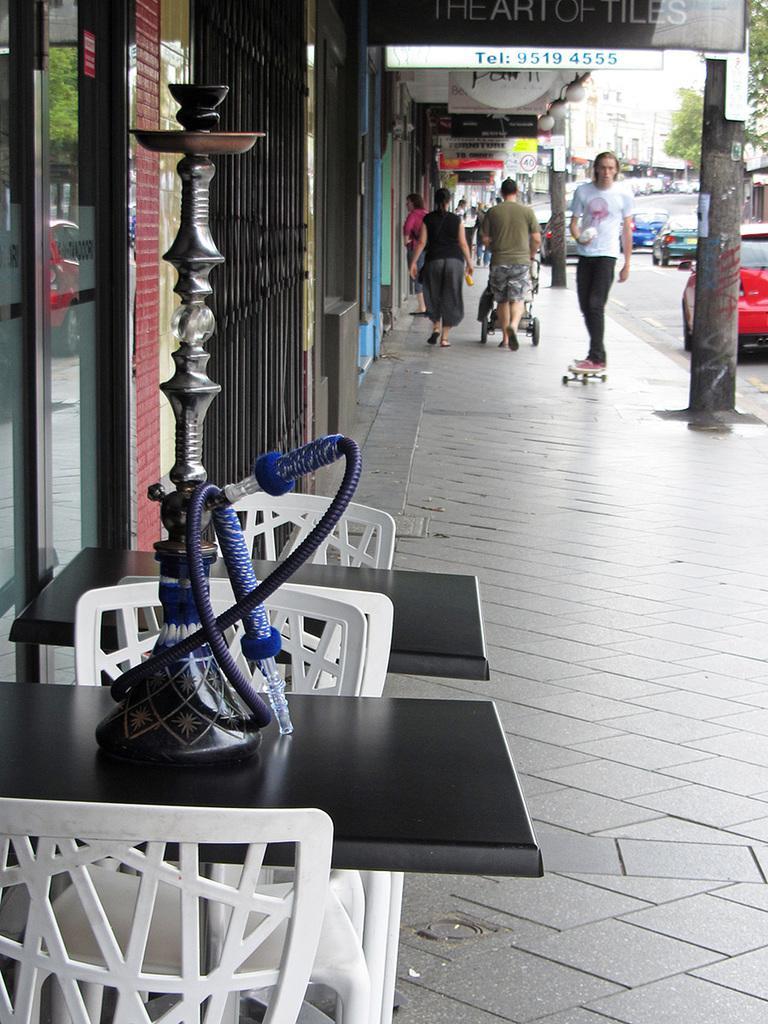Can you describe this image briefly? In this image we can see a few vehicles, there are some buildings, trees and boards with some text, also we can see some chairs and tables, on the table, we can see a hookah pot. 